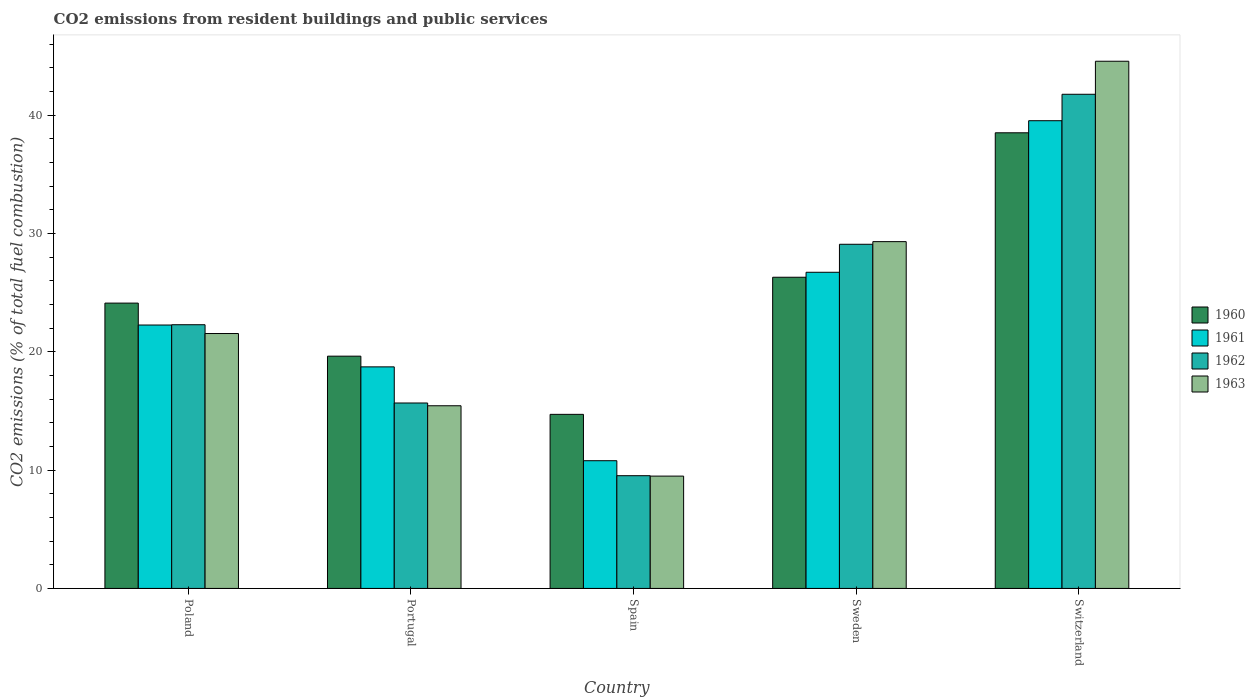How many different coloured bars are there?
Your response must be concise. 4. How many groups of bars are there?
Your answer should be very brief. 5. Are the number of bars on each tick of the X-axis equal?
Keep it short and to the point. Yes. How many bars are there on the 2nd tick from the right?
Your answer should be compact. 4. In how many cases, is the number of bars for a given country not equal to the number of legend labels?
Give a very brief answer. 0. What is the total CO2 emitted in 1963 in Spain?
Keep it short and to the point. 9.5. Across all countries, what is the maximum total CO2 emitted in 1961?
Your response must be concise. 39.54. Across all countries, what is the minimum total CO2 emitted in 1962?
Offer a very short reply. 9.53. In which country was the total CO2 emitted in 1960 maximum?
Offer a very short reply. Switzerland. In which country was the total CO2 emitted in 1962 minimum?
Keep it short and to the point. Spain. What is the total total CO2 emitted in 1960 in the graph?
Your answer should be very brief. 123.31. What is the difference between the total CO2 emitted in 1963 in Spain and that in Sweden?
Provide a succinct answer. -19.82. What is the difference between the total CO2 emitted in 1963 in Sweden and the total CO2 emitted in 1960 in Switzerland?
Your answer should be compact. -9.2. What is the average total CO2 emitted in 1963 per country?
Your answer should be compact. 24.08. What is the difference between the total CO2 emitted of/in 1962 and total CO2 emitted of/in 1961 in Switzerland?
Ensure brevity in your answer.  2.23. What is the ratio of the total CO2 emitted in 1962 in Portugal to that in Sweden?
Ensure brevity in your answer.  0.54. Is the total CO2 emitted in 1961 in Portugal less than that in Spain?
Provide a short and direct response. No. Is the difference between the total CO2 emitted in 1962 in Spain and Sweden greater than the difference between the total CO2 emitted in 1961 in Spain and Sweden?
Your answer should be very brief. No. What is the difference between the highest and the second highest total CO2 emitted in 1962?
Make the answer very short. 12.68. What is the difference between the highest and the lowest total CO2 emitted in 1962?
Your answer should be compact. 32.25. In how many countries, is the total CO2 emitted in 1962 greater than the average total CO2 emitted in 1962 taken over all countries?
Provide a short and direct response. 2. Is the sum of the total CO2 emitted in 1961 in Portugal and Switzerland greater than the maximum total CO2 emitted in 1960 across all countries?
Your answer should be compact. Yes. Is it the case that in every country, the sum of the total CO2 emitted in 1961 and total CO2 emitted in 1963 is greater than the sum of total CO2 emitted in 1960 and total CO2 emitted in 1962?
Make the answer very short. No. How many countries are there in the graph?
Keep it short and to the point. 5. What is the difference between two consecutive major ticks on the Y-axis?
Keep it short and to the point. 10. Are the values on the major ticks of Y-axis written in scientific E-notation?
Provide a succinct answer. No. Does the graph contain any zero values?
Keep it short and to the point. No. How many legend labels are there?
Give a very brief answer. 4. How are the legend labels stacked?
Your response must be concise. Vertical. What is the title of the graph?
Make the answer very short. CO2 emissions from resident buildings and public services. Does "1988" appear as one of the legend labels in the graph?
Your answer should be very brief. No. What is the label or title of the X-axis?
Make the answer very short. Country. What is the label or title of the Y-axis?
Your response must be concise. CO2 emissions (% of total fuel combustion). What is the CO2 emissions (% of total fuel combustion) in 1960 in Poland?
Ensure brevity in your answer.  24.12. What is the CO2 emissions (% of total fuel combustion) of 1961 in Poland?
Your answer should be very brief. 22.27. What is the CO2 emissions (% of total fuel combustion) of 1962 in Poland?
Offer a very short reply. 22.3. What is the CO2 emissions (% of total fuel combustion) in 1963 in Poland?
Provide a short and direct response. 21.55. What is the CO2 emissions (% of total fuel combustion) in 1960 in Portugal?
Keep it short and to the point. 19.64. What is the CO2 emissions (% of total fuel combustion) of 1961 in Portugal?
Your answer should be very brief. 18.73. What is the CO2 emissions (% of total fuel combustion) in 1962 in Portugal?
Your answer should be very brief. 15.68. What is the CO2 emissions (% of total fuel combustion) of 1963 in Portugal?
Make the answer very short. 15.44. What is the CO2 emissions (% of total fuel combustion) of 1960 in Spain?
Make the answer very short. 14.72. What is the CO2 emissions (% of total fuel combustion) in 1961 in Spain?
Keep it short and to the point. 10.8. What is the CO2 emissions (% of total fuel combustion) of 1962 in Spain?
Offer a very short reply. 9.53. What is the CO2 emissions (% of total fuel combustion) of 1963 in Spain?
Offer a terse response. 9.5. What is the CO2 emissions (% of total fuel combustion) in 1960 in Sweden?
Offer a very short reply. 26.31. What is the CO2 emissions (% of total fuel combustion) of 1961 in Sweden?
Give a very brief answer. 26.73. What is the CO2 emissions (% of total fuel combustion) of 1962 in Sweden?
Make the answer very short. 29.1. What is the CO2 emissions (% of total fuel combustion) in 1963 in Sweden?
Keep it short and to the point. 29.32. What is the CO2 emissions (% of total fuel combustion) in 1960 in Switzerland?
Provide a succinct answer. 38.52. What is the CO2 emissions (% of total fuel combustion) of 1961 in Switzerland?
Provide a short and direct response. 39.54. What is the CO2 emissions (% of total fuel combustion) of 1962 in Switzerland?
Your answer should be very brief. 41.78. What is the CO2 emissions (% of total fuel combustion) in 1963 in Switzerland?
Your answer should be compact. 44.57. Across all countries, what is the maximum CO2 emissions (% of total fuel combustion) of 1960?
Give a very brief answer. 38.52. Across all countries, what is the maximum CO2 emissions (% of total fuel combustion) of 1961?
Give a very brief answer. 39.54. Across all countries, what is the maximum CO2 emissions (% of total fuel combustion) of 1962?
Your answer should be very brief. 41.78. Across all countries, what is the maximum CO2 emissions (% of total fuel combustion) in 1963?
Make the answer very short. 44.57. Across all countries, what is the minimum CO2 emissions (% of total fuel combustion) of 1960?
Give a very brief answer. 14.72. Across all countries, what is the minimum CO2 emissions (% of total fuel combustion) of 1961?
Ensure brevity in your answer.  10.8. Across all countries, what is the minimum CO2 emissions (% of total fuel combustion) in 1962?
Offer a terse response. 9.53. Across all countries, what is the minimum CO2 emissions (% of total fuel combustion) in 1963?
Your answer should be very brief. 9.5. What is the total CO2 emissions (% of total fuel combustion) of 1960 in the graph?
Your response must be concise. 123.31. What is the total CO2 emissions (% of total fuel combustion) in 1961 in the graph?
Ensure brevity in your answer.  118.07. What is the total CO2 emissions (% of total fuel combustion) in 1962 in the graph?
Make the answer very short. 118.38. What is the total CO2 emissions (% of total fuel combustion) of 1963 in the graph?
Your answer should be compact. 120.38. What is the difference between the CO2 emissions (% of total fuel combustion) in 1960 in Poland and that in Portugal?
Offer a very short reply. 4.49. What is the difference between the CO2 emissions (% of total fuel combustion) of 1961 in Poland and that in Portugal?
Provide a short and direct response. 3.54. What is the difference between the CO2 emissions (% of total fuel combustion) of 1962 in Poland and that in Portugal?
Ensure brevity in your answer.  6.62. What is the difference between the CO2 emissions (% of total fuel combustion) of 1963 in Poland and that in Portugal?
Offer a terse response. 6.11. What is the difference between the CO2 emissions (% of total fuel combustion) of 1960 in Poland and that in Spain?
Keep it short and to the point. 9.41. What is the difference between the CO2 emissions (% of total fuel combustion) in 1961 in Poland and that in Spain?
Ensure brevity in your answer.  11.47. What is the difference between the CO2 emissions (% of total fuel combustion) of 1962 in Poland and that in Spain?
Give a very brief answer. 12.76. What is the difference between the CO2 emissions (% of total fuel combustion) of 1963 in Poland and that in Spain?
Ensure brevity in your answer.  12.05. What is the difference between the CO2 emissions (% of total fuel combustion) in 1960 in Poland and that in Sweden?
Keep it short and to the point. -2.19. What is the difference between the CO2 emissions (% of total fuel combustion) of 1961 in Poland and that in Sweden?
Keep it short and to the point. -4.46. What is the difference between the CO2 emissions (% of total fuel combustion) of 1962 in Poland and that in Sweden?
Keep it short and to the point. -6.8. What is the difference between the CO2 emissions (% of total fuel combustion) in 1963 in Poland and that in Sweden?
Provide a succinct answer. -7.77. What is the difference between the CO2 emissions (% of total fuel combustion) of 1960 in Poland and that in Switzerland?
Ensure brevity in your answer.  -14.4. What is the difference between the CO2 emissions (% of total fuel combustion) of 1961 in Poland and that in Switzerland?
Ensure brevity in your answer.  -17.27. What is the difference between the CO2 emissions (% of total fuel combustion) in 1962 in Poland and that in Switzerland?
Your answer should be compact. -19.48. What is the difference between the CO2 emissions (% of total fuel combustion) of 1963 in Poland and that in Switzerland?
Give a very brief answer. -23.02. What is the difference between the CO2 emissions (% of total fuel combustion) of 1960 in Portugal and that in Spain?
Provide a succinct answer. 4.92. What is the difference between the CO2 emissions (% of total fuel combustion) in 1961 in Portugal and that in Spain?
Offer a very short reply. 7.93. What is the difference between the CO2 emissions (% of total fuel combustion) of 1962 in Portugal and that in Spain?
Provide a succinct answer. 6.15. What is the difference between the CO2 emissions (% of total fuel combustion) in 1963 in Portugal and that in Spain?
Your answer should be very brief. 5.95. What is the difference between the CO2 emissions (% of total fuel combustion) of 1960 in Portugal and that in Sweden?
Give a very brief answer. -6.67. What is the difference between the CO2 emissions (% of total fuel combustion) in 1961 in Portugal and that in Sweden?
Make the answer very short. -8. What is the difference between the CO2 emissions (% of total fuel combustion) of 1962 in Portugal and that in Sweden?
Offer a terse response. -13.42. What is the difference between the CO2 emissions (% of total fuel combustion) in 1963 in Portugal and that in Sweden?
Provide a succinct answer. -13.88. What is the difference between the CO2 emissions (% of total fuel combustion) in 1960 in Portugal and that in Switzerland?
Provide a short and direct response. -18.88. What is the difference between the CO2 emissions (% of total fuel combustion) in 1961 in Portugal and that in Switzerland?
Ensure brevity in your answer.  -20.81. What is the difference between the CO2 emissions (% of total fuel combustion) of 1962 in Portugal and that in Switzerland?
Provide a succinct answer. -26.1. What is the difference between the CO2 emissions (% of total fuel combustion) in 1963 in Portugal and that in Switzerland?
Your response must be concise. -29.13. What is the difference between the CO2 emissions (% of total fuel combustion) of 1960 in Spain and that in Sweden?
Ensure brevity in your answer.  -11.59. What is the difference between the CO2 emissions (% of total fuel combustion) of 1961 in Spain and that in Sweden?
Your answer should be very brief. -15.93. What is the difference between the CO2 emissions (% of total fuel combustion) of 1962 in Spain and that in Sweden?
Offer a terse response. -19.57. What is the difference between the CO2 emissions (% of total fuel combustion) in 1963 in Spain and that in Sweden?
Provide a succinct answer. -19.82. What is the difference between the CO2 emissions (% of total fuel combustion) of 1960 in Spain and that in Switzerland?
Offer a terse response. -23.8. What is the difference between the CO2 emissions (% of total fuel combustion) in 1961 in Spain and that in Switzerland?
Your response must be concise. -28.75. What is the difference between the CO2 emissions (% of total fuel combustion) in 1962 in Spain and that in Switzerland?
Keep it short and to the point. -32.25. What is the difference between the CO2 emissions (% of total fuel combustion) of 1963 in Spain and that in Switzerland?
Keep it short and to the point. -35.07. What is the difference between the CO2 emissions (% of total fuel combustion) in 1960 in Sweden and that in Switzerland?
Offer a terse response. -12.21. What is the difference between the CO2 emissions (% of total fuel combustion) of 1961 in Sweden and that in Switzerland?
Your answer should be compact. -12.81. What is the difference between the CO2 emissions (% of total fuel combustion) of 1962 in Sweden and that in Switzerland?
Give a very brief answer. -12.68. What is the difference between the CO2 emissions (% of total fuel combustion) in 1963 in Sweden and that in Switzerland?
Your response must be concise. -15.25. What is the difference between the CO2 emissions (% of total fuel combustion) in 1960 in Poland and the CO2 emissions (% of total fuel combustion) in 1961 in Portugal?
Your response must be concise. 5.39. What is the difference between the CO2 emissions (% of total fuel combustion) of 1960 in Poland and the CO2 emissions (% of total fuel combustion) of 1962 in Portugal?
Ensure brevity in your answer.  8.44. What is the difference between the CO2 emissions (% of total fuel combustion) in 1960 in Poland and the CO2 emissions (% of total fuel combustion) in 1963 in Portugal?
Offer a terse response. 8.68. What is the difference between the CO2 emissions (% of total fuel combustion) of 1961 in Poland and the CO2 emissions (% of total fuel combustion) of 1962 in Portugal?
Offer a very short reply. 6.59. What is the difference between the CO2 emissions (% of total fuel combustion) of 1961 in Poland and the CO2 emissions (% of total fuel combustion) of 1963 in Portugal?
Keep it short and to the point. 6.83. What is the difference between the CO2 emissions (% of total fuel combustion) in 1962 in Poland and the CO2 emissions (% of total fuel combustion) in 1963 in Portugal?
Offer a very short reply. 6.85. What is the difference between the CO2 emissions (% of total fuel combustion) of 1960 in Poland and the CO2 emissions (% of total fuel combustion) of 1961 in Spain?
Your response must be concise. 13.32. What is the difference between the CO2 emissions (% of total fuel combustion) of 1960 in Poland and the CO2 emissions (% of total fuel combustion) of 1962 in Spain?
Offer a very short reply. 14.59. What is the difference between the CO2 emissions (% of total fuel combustion) in 1960 in Poland and the CO2 emissions (% of total fuel combustion) in 1963 in Spain?
Ensure brevity in your answer.  14.63. What is the difference between the CO2 emissions (% of total fuel combustion) in 1961 in Poland and the CO2 emissions (% of total fuel combustion) in 1962 in Spain?
Give a very brief answer. 12.74. What is the difference between the CO2 emissions (% of total fuel combustion) of 1961 in Poland and the CO2 emissions (% of total fuel combustion) of 1963 in Spain?
Offer a very short reply. 12.77. What is the difference between the CO2 emissions (% of total fuel combustion) of 1962 in Poland and the CO2 emissions (% of total fuel combustion) of 1963 in Spain?
Your answer should be compact. 12.8. What is the difference between the CO2 emissions (% of total fuel combustion) in 1960 in Poland and the CO2 emissions (% of total fuel combustion) in 1961 in Sweden?
Make the answer very short. -2.61. What is the difference between the CO2 emissions (% of total fuel combustion) in 1960 in Poland and the CO2 emissions (% of total fuel combustion) in 1962 in Sweden?
Make the answer very short. -4.97. What is the difference between the CO2 emissions (% of total fuel combustion) in 1960 in Poland and the CO2 emissions (% of total fuel combustion) in 1963 in Sweden?
Offer a terse response. -5.2. What is the difference between the CO2 emissions (% of total fuel combustion) of 1961 in Poland and the CO2 emissions (% of total fuel combustion) of 1962 in Sweden?
Ensure brevity in your answer.  -6.83. What is the difference between the CO2 emissions (% of total fuel combustion) of 1961 in Poland and the CO2 emissions (% of total fuel combustion) of 1963 in Sweden?
Keep it short and to the point. -7.05. What is the difference between the CO2 emissions (% of total fuel combustion) in 1962 in Poland and the CO2 emissions (% of total fuel combustion) in 1963 in Sweden?
Offer a very short reply. -7.02. What is the difference between the CO2 emissions (% of total fuel combustion) of 1960 in Poland and the CO2 emissions (% of total fuel combustion) of 1961 in Switzerland?
Your answer should be compact. -15.42. What is the difference between the CO2 emissions (% of total fuel combustion) in 1960 in Poland and the CO2 emissions (% of total fuel combustion) in 1962 in Switzerland?
Ensure brevity in your answer.  -17.66. What is the difference between the CO2 emissions (% of total fuel combustion) in 1960 in Poland and the CO2 emissions (% of total fuel combustion) in 1963 in Switzerland?
Offer a very short reply. -20.45. What is the difference between the CO2 emissions (% of total fuel combustion) in 1961 in Poland and the CO2 emissions (% of total fuel combustion) in 1962 in Switzerland?
Your response must be concise. -19.51. What is the difference between the CO2 emissions (% of total fuel combustion) of 1961 in Poland and the CO2 emissions (% of total fuel combustion) of 1963 in Switzerland?
Provide a succinct answer. -22.3. What is the difference between the CO2 emissions (% of total fuel combustion) of 1962 in Poland and the CO2 emissions (% of total fuel combustion) of 1963 in Switzerland?
Make the answer very short. -22.28. What is the difference between the CO2 emissions (% of total fuel combustion) in 1960 in Portugal and the CO2 emissions (% of total fuel combustion) in 1961 in Spain?
Offer a very short reply. 8.84. What is the difference between the CO2 emissions (% of total fuel combustion) in 1960 in Portugal and the CO2 emissions (% of total fuel combustion) in 1962 in Spain?
Your answer should be very brief. 10.11. What is the difference between the CO2 emissions (% of total fuel combustion) of 1960 in Portugal and the CO2 emissions (% of total fuel combustion) of 1963 in Spain?
Your answer should be compact. 10.14. What is the difference between the CO2 emissions (% of total fuel combustion) in 1961 in Portugal and the CO2 emissions (% of total fuel combustion) in 1962 in Spain?
Offer a terse response. 9.2. What is the difference between the CO2 emissions (% of total fuel combustion) in 1961 in Portugal and the CO2 emissions (% of total fuel combustion) in 1963 in Spain?
Ensure brevity in your answer.  9.23. What is the difference between the CO2 emissions (% of total fuel combustion) in 1962 in Portugal and the CO2 emissions (% of total fuel combustion) in 1963 in Spain?
Offer a very short reply. 6.18. What is the difference between the CO2 emissions (% of total fuel combustion) of 1960 in Portugal and the CO2 emissions (% of total fuel combustion) of 1961 in Sweden?
Give a very brief answer. -7.09. What is the difference between the CO2 emissions (% of total fuel combustion) in 1960 in Portugal and the CO2 emissions (% of total fuel combustion) in 1962 in Sweden?
Make the answer very short. -9.46. What is the difference between the CO2 emissions (% of total fuel combustion) in 1960 in Portugal and the CO2 emissions (% of total fuel combustion) in 1963 in Sweden?
Give a very brief answer. -9.68. What is the difference between the CO2 emissions (% of total fuel combustion) in 1961 in Portugal and the CO2 emissions (% of total fuel combustion) in 1962 in Sweden?
Your response must be concise. -10.36. What is the difference between the CO2 emissions (% of total fuel combustion) in 1961 in Portugal and the CO2 emissions (% of total fuel combustion) in 1963 in Sweden?
Your answer should be very brief. -10.59. What is the difference between the CO2 emissions (% of total fuel combustion) of 1962 in Portugal and the CO2 emissions (% of total fuel combustion) of 1963 in Sweden?
Make the answer very short. -13.64. What is the difference between the CO2 emissions (% of total fuel combustion) in 1960 in Portugal and the CO2 emissions (% of total fuel combustion) in 1961 in Switzerland?
Keep it short and to the point. -19.91. What is the difference between the CO2 emissions (% of total fuel combustion) in 1960 in Portugal and the CO2 emissions (% of total fuel combustion) in 1962 in Switzerland?
Your response must be concise. -22.14. What is the difference between the CO2 emissions (% of total fuel combustion) of 1960 in Portugal and the CO2 emissions (% of total fuel combustion) of 1963 in Switzerland?
Your answer should be compact. -24.93. What is the difference between the CO2 emissions (% of total fuel combustion) of 1961 in Portugal and the CO2 emissions (% of total fuel combustion) of 1962 in Switzerland?
Provide a succinct answer. -23.05. What is the difference between the CO2 emissions (% of total fuel combustion) of 1961 in Portugal and the CO2 emissions (% of total fuel combustion) of 1963 in Switzerland?
Your answer should be compact. -25.84. What is the difference between the CO2 emissions (% of total fuel combustion) of 1962 in Portugal and the CO2 emissions (% of total fuel combustion) of 1963 in Switzerland?
Your answer should be very brief. -28.89. What is the difference between the CO2 emissions (% of total fuel combustion) of 1960 in Spain and the CO2 emissions (% of total fuel combustion) of 1961 in Sweden?
Give a very brief answer. -12.01. What is the difference between the CO2 emissions (% of total fuel combustion) in 1960 in Spain and the CO2 emissions (% of total fuel combustion) in 1962 in Sweden?
Ensure brevity in your answer.  -14.38. What is the difference between the CO2 emissions (% of total fuel combustion) of 1960 in Spain and the CO2 emissions (% of total fuel combustion) of 1963 in Sweden?
Offer a terse response. -14.6. What is the difference between the CO2 emissions (% of total fuel combustion) of 1961 in Spain and the CO2 emissions (% of total fuel combustion) of 1962 in Sweden?
Your answer should be compact. -18.3. What is the difference between the CO2 emissions (% of total fuel combustion) of 1961 in Spain and the CO2 emissions (% of total fuel combustion) of 1963 in Sweden?
Your answer should be compact. -18.52. What is the difference between the CO2 emissions (% of total fuel combustion) of 1962 in Spain and the CO2 emissions (% of total fuel combustion) of 1963 in Sweden?
Your answer should be very brief. -19.79. What is the difference between the CO2 emissions (% of total fuel combustion) in 1960 in Spain and the CO2 emissions (% of total fuel combustion) in 1961 in Switzerland?
Provide a succinct answer. -24.83. What is the difference between the CO2 emissions (% of total fuel combustion) of 1960 in Spain and the CO2 emissions (% of total fuel combustion) of 1962 in Switzerland?
Provide a short and direct response. -27.06. What is the difference between the CO2 emissions (% of total fuel combustion) in 1960 in Spain and the CO2 emissions (% of total fuel combustion) in 1963 in Switzerland?
Offer a terse response. -29.85. What is the difference between the CO2 emissions (% of total fuel combustion) of 1961 in Spain and the CO2 emissions (% of total fuel combustion) of 1962 in Switzerland?
Your answer should be compact. -30.98. What is the difference between the CO2 emissions (% of total fuel combustion) in 1961 in Spain and the CO2 emissions (% of total fuel combustion) in 1963 in Switzerland?
Ensure brevity in your answer.  -33.77. What is the difference between the CO2 emissions (% of total fuel combustion) in 1962 in Spain and the CO2 emissions (% of total fuel combustion) in 1963 in Switzerland?
Give a very brief answer. -35.04. What is the difference between the CO2 emissions (% of total fuel combustion) of 1960 in Sweden and the CO2 emissions (% of total fuel combustion) of 1961 in Switzerland?
Offer a very short reply. -13.23. What is the difference between the CO2 emissions (% of total fuel combustion) of 1960 in Sweden and the CO2 emissions (% of total fuel combustion) of 1962 in Switzerland?
Offer a very short reply. -15.47. What is the difference between the CO2 emissions (% of total fuel combustion) of 1960 in Sweden and the CO2 emissions (% of total fuel combustion) of 1963 in Switzerland?
Provide a succinct answer. -18.26. What is the difference between the CO2 emissions (% of total fuel combustion) of 1961 in Sweden and the CO2 emissions (% of total fuel combustion) of 1962 in Switzerland?
Offer a terse response. -15.05. What is the difference between the CO2 emissions (% of total fuel combustion) in 1961 in Sweden and the CO2 emissions (% of total fuel combustion) in 1963 in Switzerland?
Keep it short and to the point. -17.84. What is the difference between the CO2 emissions (% of total fuel combustion) of 1962 in Sweden and the CO2 emissions (% of total fuel combustion) of 1963 in Switzerland?
Your answer should be very brief. -15.47. What is the average CO2 emissions (% of total fuel combustion) of 1960 per country?
Provide a succinct answer. 24.66. What is the average CO2 emissions (% of total fuel combustion) in 1961 per country?
Offer a terse response. 23.61. What is the average CO2 emissions (% of total fuel combustion) in 1962 per country?
Offer a very short reply. 23.68. What is the average CO2 emissions (% of total fuel combustion) in 1963 per country?
Make the answer very short. 24.08. What is the difference between the CO2 emissions (% of total fuel combustion) in 1960 and CO2 emissions (% of total fuel combustion) in 1961 in Poland?
Your answer should be compact. 1.85. What is the difference between the CO2 emissions (% of total fuel combustion) in 1960 and CO2 emissions (% of total fuel combustion) in 1962 in Poland?
Provide a succinct answer. 1.83. What is the difference between the CO2 emissions (% of total fuel combustion) in 1960 and CO2 emissions (% of total fuel combustion) in 1963 in Poland?
Offer a very short reply. 2.57. What is the difference between the CO2 emissions (% of total fuel combustion) of 1961 and CO2 emissions (% of total fuel combustion) of 1962 in Poland?
Provide a short and direct response. -0.02. What is the difference between the CO2 emissions (% of total fuel combustion) in 1961 and CO2 emissions (% of total fuel combustion) in 1963 in Poland?
Make the answer very short. 0.72. What is the difference between the CO2 emissions (% of total fuel combustion) of 1962 and CO2 emissions (% of total fuel combustion) of 1963 in Poland?
Your response must be concise. 0.74. What is the difference between the CO2 emissions (% of total fuel combustion) of 1960 and CO2 emissions (% of total fuel combustion) of 1961 in Portugal?
Your answer should be very brief. 0.91. What is the difference between the CO2 emissions (% of total fuel combustion) of 1960 and CO2 emissions (% of total fuel combustion) of 1962 in Portugal?
Your answer should be very brief. 3.96. What is the difference between the CO2 emissions (% of total fuel combustion) of 1960 and CO2 emissions (% of total fuel combustion) of 1963 in Portugal?
Provide a succinct answer. 4.19. What is the difference between the CO2 emissions (% of total fuel combustion) of 1961 and CO2 emissions (% of total fuel combustion) of 1962 in Portugal?
Make the answer very short. 3.05. What is the difference between the CO2 emissions (% of total fuel combustion) of 1961 and CO2 emissions (% of total fuel combustion) of 1963 in Portugal?
Keep it short and to the point. 3.29. What is the difference between the CO2 emissions (% of total fuel combustion) of 1962 and CO2 emissions (% of total fuel combustion) of 1963 in Portugal?
Offer a terse response. 0.23. What is the difference between the CO2 emissions (% of total fuel combustion) of 1960 and CO2 emissions (% of total fuel combustion) of 1961 in Spain?
Provide a succinct answer. 3.92. What is the difference between the CO2 emissions (% of total fuel combustion) of 1960 and CO2 emissions (% of total fuel combustion) of 1962 in Spain?
Offer a terse response. 5.19. What is the difference between the CO2 emissions (% of total fuel combustion) of 1960 and CO2 emissions (% of total fuel combustion) of 1963 in Spain?
Ensure brevity in your answer.  5.22. What is the difference between the CO2 emissions (% of total fuel combustion) of 1961 and CO2 emissions (% of total fuel combustion) of 1962 in Spain?
Provide a succinct answer. 1.27. What is the difference between the CO2 emissions (% of total fuel combustion) in 1961 and CO2 emissions (% of total fuel combustion) in 1963 in Spain?
Ensure brevity in your answer.  1.3. What is the difference between the CO2 emissions (% of total fuel combustion) of 1962 and CO2 emissions (% of total fuel combustion) of 1963 in Spain?
Keep it short and to the point. 0.03. What is the difference between the CO2 emissions (% of total fuel combustion) of 1960 and CO2 emissions (% of total fuel combustion) of 1961 in Sweden?
Give a very brief answer. -0.42. What is the difference between the CO2 emissions (% of total fuel combustion) in 1960 and CO2 emissions (% of total fuel combustion) in 1962 in Sweden?
Provide a succinct answer. -2.79. What is the difference between the CO2 emissions (% of total fuel combustion) in 1960 and CO2 emissions (% of total fuel combustion) in 1963 in Sweden?
Offer a terse response. -3.01. What is the difference between the CO2 emissions (% of total fuel combustion) in 1961 and CO2 emissions (% of total fuel combustion) in 1962 in Sweden?
Your answer should be very brief. -2.37. What is the difference between the CO2 emissions (% of total fuel combustion) in 1961 and CO2 emissions (% of total fuel combustion) in 1963 in Sweden?
Your response must be concise. -2.59. What is the difference between the CO2 emissions (% of total fuel combustion) of 1962 and CO2 emissions (% of total fuel combustion) of 1963 in Sweden?
Your answer should be very brief. -0.22. What is the difference between the CO2 emissions (% of total fuel combustion) in 1960 and CO2 emissions (% of total fuel combustion) in 1961 in Switzerland?
Ensure brevity in your answer.  -1.02. What is the difference between the CO2 emissions (% of total fuel combustion) of 1960 and CO2 emissions (% of total fuel combustion) of 1962 in Switzerland?
Make the answer very short. -3.26. What is the difference between the CO2 emissions (% of total fuel combustion) of 1960 and CO2 emissions (% of total fuel combustion) of 1963 in Switzerland?
Keep it short and to the point. -6.05. What is the difference between the CO2 emissions (% of total fuel combustion) of 1961 and CO2 emissions (% of total fuel combustion) of 1962 in Switzerland?
Offer a very short reply. -2.23. What is the difference between the CO2 emissions (% of total fuel combustion) of 1961 and CO2 emissions (% of total fuel combustion) of 1963 in Switzerland?
Your answer should be compact. -5.03. What is the difference between the CO2 emissions (% of total fuel combustion) of 1962 and CO2 emissions (% of total fuel combustion) of 1963 in Switzerland?
Your answer should be very brief. -2.79. What is the ratio of the CO2 emissions (% of total fuel combustion) of 1960 in Poland to that in Portugal?
Your response must be concise. 1.23. What is the ratio of the CO2 emissions (% of total fuel combustion) in 1961 in Poland to that in Portugal?
Make the answer very short. 1.19. What is the ratio of the CO2 emissions (% of total fuel combustion) in 1962 in Poland to that in Portugal?
Your response must be concise. 1.42. What is the ratio of the CO2 emissions (% of total fuel combustion) in 1963 in Poland to that in Portugal?
Ensure brevity in your answer.  1.4. What is the ratio of the CO2 emissions (% of total fuel combustion) in 1960 in Poland to that in Spain?
Provide a short and direct response. 1.64. What is the ratio of the CO2 emissions (% of total fuel combustion) in 1961 in Poland to that in Spain?
Your answer should be compact. 2.06. What is the ratio of the CO2 emissions (% of total fuel combustion) in 1962 in Poland to that in Spain?
Offer a very short reply. 2.34. What is the ratio of the CO2 emissions (% of total fuel combustion) of 1963 in Poland to that in Spain?
Ensure brevity in your answer.  2.27. What is the ratio of the CO2 emissions (% of total fuel combustion) in 1960 in Poland to that in Sweden?
Ensure brevity in your answer.  0.92. What is the ratio of the CO2 emissions (% of total fuel combustion) in 1961 in Poland to that in Sweden?
Provide a succinct answer. 0.83. What is the ratio of the CO2 emissions (% of total fuel combustion) in 1962 in Poland to that in Sweden?
Keep it short and to the point. 0.77. What is the ratio of the CO2 emissions (% of total fuel combustion) of 1963 in Poland to that in Sweden?
Your answer should be very brief. 0.73. What is the ratio of the CO2 emissions (% of total fuel combustion) in 1960 in Poland to that in Switzerland?
Your answer should be compact. 0.63. What is the ratio of the CO2 emissions (% of total fuel combustion) in 1961 in Poland to that in Switzerland?
Keep it short and to the point. 0.56. What is the ratio of the CO2 emissions (% of total fuel combustion) of 1962 in Poland to that in Switzerland?
Offer a terse response. 0.53. What is the ratio of the CO2 emissions (% of total fuel combustion) in 1963 in Poland to that in Switzerland?
Keep it short and to the point. 0.48. What is the ratio of the CO2 emissions (% of total fuel combustion) in 1960 in Portugal to that in Spain?
Provide a short and direct response. 1.33. What is the ratio of the CO2 emissions (% of total fuel combustion) of 1961 in Portugal to that in Spain?
Offer a terse response. 1.73. What is the ratio of the CO2 emissions (% of total fuel combustion) of 1962 in Portugal to that in Spain?
Make the answer very short. 1.64. What is the ratio of the CO2 emissions (% of total fuel combustion) in 1963 in Portugal to that in Spain?
Keep it short and to the point. 1.63. What is the ratio of the CO2 emissions (% of total fuel combustion) of 1960 in Portugal to that in Sweden?
Provide a short and direct response. 0.75. What is the ratio of the CO2 emissions (% of total fuel combustion) in 1961 in Portugal to that in Sweden?
Your answer should be compact. 0.7. What is the ratio of the CO2 emissions (% of total fuel combustion) of 1962 in Portugal to that in Sweden?
Your response must be concise. 0.54. What is the ratio of the CO2 emissions (% of total fuel combustion) of 1963 in Portugal to that in Sweden?
Your response must be concise. 0.53. What is the ratio of the CO2 emissions (% of total fuel combustion) of 1960 in Portugal to that in Switzerland?
Your answer should be compact. 0.51. What is the ratio of the CO2 emissions (% of total fuel combustion) in 1961 in Portugal to that in Switzerland?
Your answer should be very brief. 0.47. What is the ratio of the CO2 emissions (% of total fuel combustion) of 1962 in Portugal to that in Switzerland?
Provide a succinct answer. 0.38. What is the ratio of the CO2 emissions (% of total fuel combustion) of 1963 in Portugal to that in Switzerland?
Your answer should be very brief. 0.35. What is the ratio of the CO2 emissions (% of total fuel combustion) of 1960 in Spain to that in Sweden?
Your answer should be compact. 0.56. What is the ratio of the CO2 emissions (% of total fuel combustion) in 1961 in Spain to that in Sweden?
Give a very brief answer. 0.4. What is the ratio of the CO2 emissions (% of total fuel combustion) of 1962 in Spain to that in Sweden?
Offer a very short reply. 0.33. What is the ratio of the CO2 emissions (% of total fuel combustion) in 1963 in Spain to that in Sweden?
Your response must be concise. 0.32. What is the ratio of the CO2 emissions (% of total fuel combustion) of 1960 in Spain to that in Switzerland?
Your response must be concise. 0.38. What is the ratio of the CO2 emissions (% of total fuel combustion) of 1961 in Spain to that in Switzerland?
Provide a short and direct response. 0.27. What is the ratio of the CO2 emissions (% of total fuel combustion) of 1962 in Spain to that in Switzerland?
Provide a short and direct response. 0.23. What is the ratio of the CO2 emissions (% of total fuel combustion) of 1963 in Spain to that in Switzerland?
Make the answer very short. 0.21. What is the ratio of the CO2 emissions (% of total fuel combustion) in 1960 in Sweden to that in Switzerland?
Give a very brief answer. 0.68. What is the ratio of the CO2 emissions (% of total fuel combustion) in 1961 in Sweden to that in Switzerland?
Your answer should be compact. 0.68. What is the ratio of the CO2 emissions (% of total fuel combustion) in 1962 in Sweden to that in Switzerland?
Your response must be concise. 0.7. What is the ratio of the CO2 emissions (% of total fuel combustion) of 1963 in Sweden to that in Switzerland?
Ensure brevity in your answer.  0.66. What is the difference between the highest and the second highest CO2 emissions (% of total fuel combustion) in 1960?
Offer a terse response. 12.21. What is the difference between the highest and the second highest CO2 emissions (% of total fuel combustion) in 1961?
Ensure brevity in your answer.  12.81. What is the difference between the highest and the second highest CO2 emissions (% of total fuel combustion) in 1962?
Offer a very short reply. 12.68. What is the difference between the highest and the second highest CO2 emissions (% of total fuel combustion) in 1963?
Your answer should be very brief. 15.25. What is the difference between the highest and the lowest CO2 emissions (% of total fuel combustion) in 1960?
Offer a terse response. 23.8. What is the difference between the highest and the lowest CO2 emissions (% of total fuel combustion) in 1961?
Offer a very short reply. 28.75. What is the difference between the highest and the lowest CO2 emissions (% of total fuel combustion) in 1962?
Your answer should be compact. 32.25. What is the difference between the highest and the lowest CO2 emissions (% of total fuel combustion) in 1963?
Make the answer very short. 35.07. 